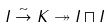<formula> <loc_0><loc_0><loc_500><loc_500>I \stackrel { \sim } \to K \twoheadrightarrow I \sqcap I</formula> 